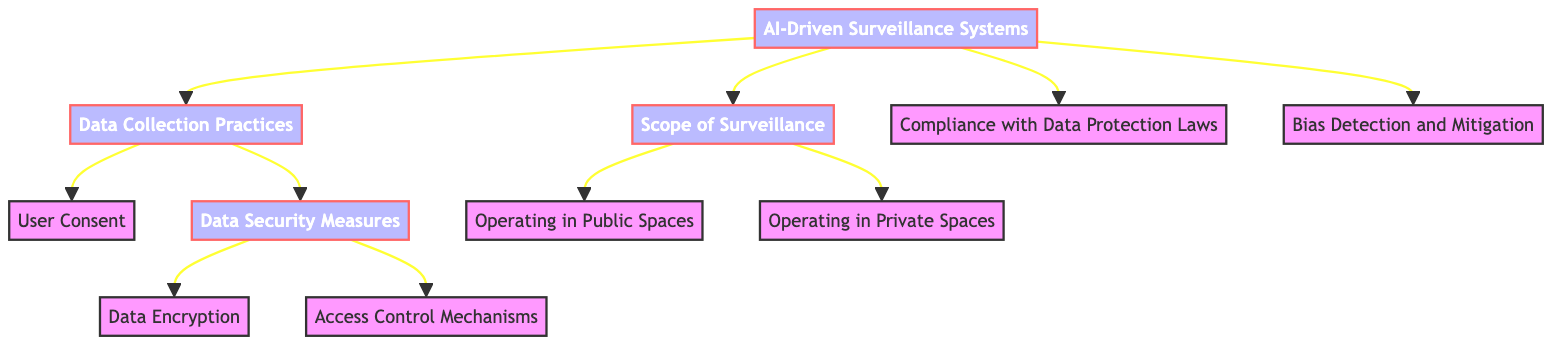What is the total number of nodes in the diagram? There are 11 nodes visible in the diagram, which includes the root node and all decision nodes and terminal nodes.
Answer: 11 What is the first decision made from the root? The first decision made from the root is "Data Collection Practices," which branches off directly from the main node.
Answer: Data Collection Practices How many edges connect to the node "Data Security Measures"? There are 2 edges that connect to the "Data Security Measures" node, which are one from "Data Collection Practices" and the other connecting to the nodes under it, "Data Encryption" and "Access Control Mechanisms."
Answer: 2 What are the two scopes of surveillance identified in the diagram? The two scopes of surveillance identified are "Operating in Public Spaces" and "Operating in Private Spaces," both branching off from the "Scope of Surveillance" node.
Answer: Operating in Public Spaces, Operating in Private Spaces What decision addresses user consent in the data collection process? The decision that addresses user consent in the data collection process is labeled "User Consent," which is a direct outcome of the "Data Collection Practices" node.
Answer: User Consent What is necessary for a system to ensure in terms of compliance related to user data? The system must ensure "Compliance with Data Protection Laws," which is one of the decision branches stemming from the root node.
Answer: Compliance with Data Protection Laws Which node relates to controlling access to data? The node that relates to controlling access to data is "Access Control Mechanisms," which is a decision that branches from "Data Security Measures."
Answer: Access Control Mechanisms How is data security improved according to the diagram? Data security is improved through "Data Encryption" and "Access Control Mechanisms," both of which are decisions branching from the "Data Security Measures" node.
Answer: Data Encryption, Access Control Mechanisms What is one potential ethical concern represented in the diagram related to biased algorithms? The potential ethical concern represented is "Bias Detection and Mitigation," a decision node that addresses biases in AI-driven systems.
Answer: Bias Detection and Mitigation 